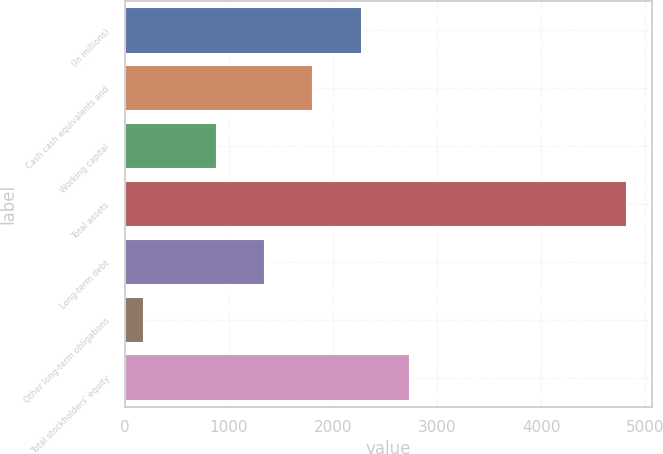Convert chart to OTSL. <chart><loc_0><loc_0><loc_500><loc_500><bar_chart><fcel>(In millions)<fcel>Cash cash equivalents and<fcel>Working capital<fcel>Total assets<fcel>Long-term debt<fcel>Other long-term obligations<fcel>Total stockholders' equity<nl><fcel>2275.7<fcel>1811.8<fcel>884<fcel>4826<fcel>1347.9<fcel>187<fcel>2739.6<nl></chart> 